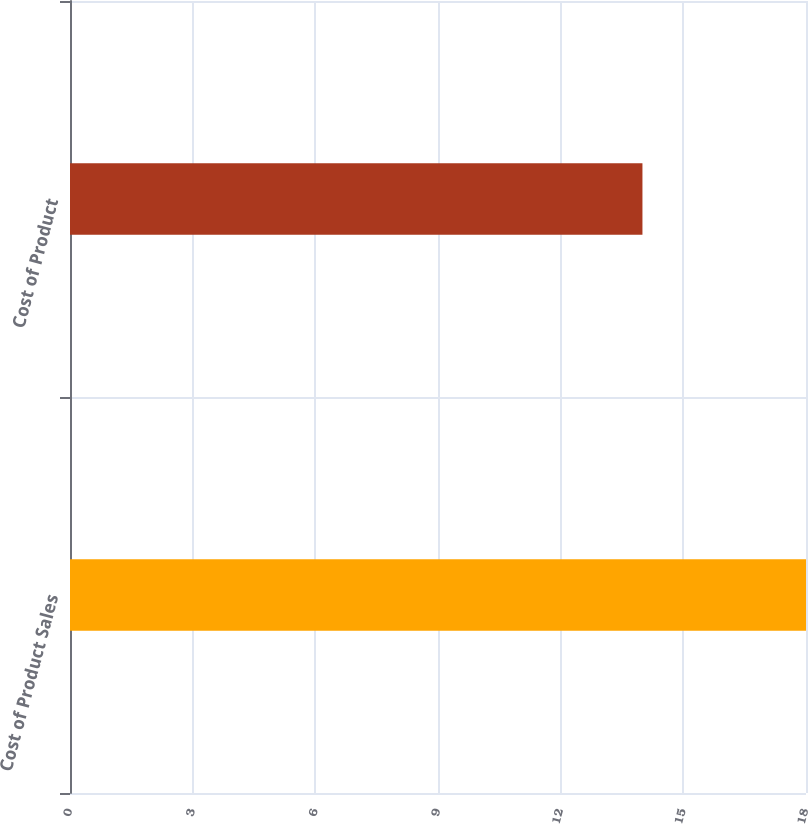Convert chart to OTSL. <chart><loc_0><loc_0><loc_500><loc_500><bar_chart><fcel>Cost of Product Sales<fcel>Cost of Product<nl><fcel>18<fcel>14<nl></chart> 